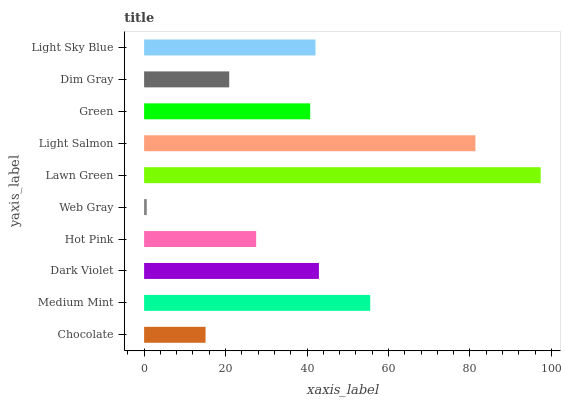Is Web Gray the minimum?
Answer yes or no. Yes. Is Lawn Green the maximum?
Answer yes or no. Yes. Is Medium Mint the minimum?
Answer yes or no. No. Is Medium Mint the maximum?
Answer yes or no. No. Is Medium Mint greater than Chocolate?
Answer yes or no. Yes. Is Chocolate less than Medium Mint?
Answer yes or no. Yes. Is Chocolate greater than Medium Mint?
Answer yes or no. No. Is Medium Mint less than Chocolate?
Answer yes or no. No. Is Light Sky Blue the high median?
Answer yes or no. Yes. Is Green the low median?
Answer yes or no. Yes. Is Medium Mint the high median?
Answer yes or no. No. Is Dim Gray the low median?
Answer yes or no. No. 